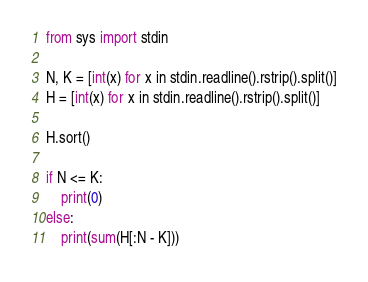Convert code to text. <code><loc_0><loc_0><loc_500><loc_500><_Python_>from sys import stdin

N, K = [int(x) for x in stdin.readline().rstrip().split()]
H = [int(x) for x in stdin.readline().rstrip().split()]

H.sort()

if N <= K:
    print(0)
else:
    print(sum(H[:N - K]))
</code> 